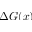Convert formula to latex. <formula><loc_0><loc_0><loc_500><loc_500>\Delta G ( x )</formula> 